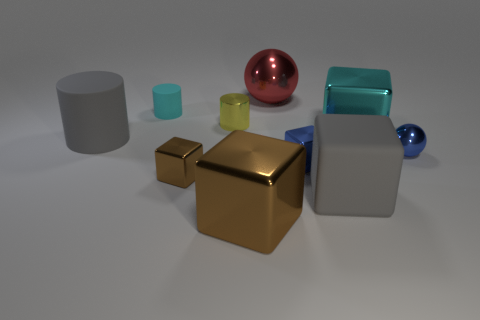Subtract all large cyan shiny blocks. How many blocks are left? 4 Subtract all blue blocks. How many blocks are left? 4 Subtract all spheres. How many objects are left? 8 Subtract 1 spheres. How many spheres are left? 1 Subtract 1 gray cylinders. How many objects are left? 9 Subtract all green balls. Subtract all green cylinders. How many balls are left? 2 Subtract all blue cylinders. How many brown spheres are left? 0 Subtract all large cyan cubes. Subtract all large rubber cylinders. How many objects are left? 8 Add 3 cyan blocks. How many cyan blocks are left? 4 Add 5 purple metal cubes. How many purple metal cubes exist? 5 